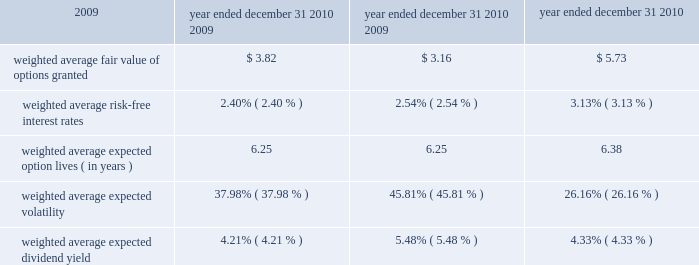Kimco realty corporation and subsidiaries notes to consolidated financial statements , continued other 2014 in connection with the construction of its development projects and related infrastructure , certain public agencies require posting of performance and surety bonds to guarantee that the company 2019s obligations are satisfied .
These bonds expire upon the completion of the improvements and infrastructure .
As of december 31 , 2010 , there were approximately $ 45.3 million in performance and surety bonds outstanding .
As of december 31 , 2010 , the company had accrued $ 3.8 million in connection with a legal claim related to a previously sold ground-up development project .
The company is currently negotiating with the plaintiff to settle this claim and believes that the prob- able settlement amount will approximate the amount accrued .
The company is subject to various other legal proceedings and claims that arise in the ordinary course of business .
Management believes that the final outcome of such matters will not have a material adverse effect on the financial position , results of operations or liquidity of the company .
23 .
Incentive plans : the company maintains two equity participation plans , the second amended and restated 1998 equity participation plan ( the 201cprior plan 201d ) and the 2010 equity participation plan ( the 201c2010 plan 201d ) ( collectively , the 201cplans 201d ) .
The prior plan provides for a maxi- mum of 47000000 shares of the company 2019s common stock to be issued for qualified and non-qualified options and restricted stock grants .
The 2010 plan provides for a maximum of 5000000 shares of the company 2019s common stock to be issued for qualified and non-qualified options , restricted stock , performance awards and other awards , plus the number of shares of common stock which are or become available for issuance under the prior plan and which are not thereafter issued under the prior plan , subject to certain conditions .
Unless otherwise determined by the board of directors at its sole discretion , options granted under the plans generally vest ratably over a range of three to five years , expire ten years from the date of grant and are exercisable at the market price on the date of grant .
Restricted stock grants generally vest ( i ) 100% ( 100 % ) on the fourth or fifth anniversary of the grant , ( ii ) ratably over three or four years or ( iii ) over three years at 50% ( 50 % ) after two years and 50% ( 50 % ) after the third year .
Performance share awards may provide a right to receive shares of restricted stock based on the company 2019s performance relative to its peers , as defined , or based on other performance criteria as determined by the board of directors .
In addition , the plans provide for the granting of certain options and restricted stock to each of the company 2019s non-employee directors ( the 201cindependent directors 201d ) and permits such independent directors to elect to receive deferred stock awards in lieu of directors 2019 fees .
The company accounts for stock options in accordance with fasb 2019s compensation 2014stock compensation guidance which requires that all share based payments to employees , including grants of employee stock options , be recognized in the statement of operations over the service period based on their fair values .
The fair value of each option award is estimated on the date of grant using the black-scholes option pricing formula .
The assump- tion for expected volatility has a significant affect on the grant date fair value .
Volatility is determined based on the historical equity of common stock for the most recent historical period equal to the expected term of the options plus an implied volatility measure .
The more significant assumptions underlying the determination of fair values for options granted during 2010 , 2009 and 2008 were as follows : year ended december 31 , 2010 2009 2008 .

What is the growth rate in weighted average fair value of options granted in 2009? 
Computations: ((3.16 - 5.73) / 5.73)
Answer: -0.44852. Kimco realty corporation and subsidiaries notes to consolidated financial statements , continued other 2014 in connection with the construction of its development projects and related infrastructure , certain public agencies require posting of performance and surety bonds to guarantee that the company 2019s obligations are satisfied .
These bonds expire upon the completion of the improvements and infrastructure .
As of december 31 , 2010 , there were approximately $ 45.3 million in performance and surety bonds outstanding .
As of december 31 , 2010 , the company had accrued $ 3.8 million in connection with a legal claim related to a previously sold ground-up development project .
The company is currently negotiating with the plaintiff to settle this claim and believes that the prob- able settlement amount will approximate the amount accrued .
The company is subject to various other legal proceedings and claims that arise in the ordinary course of business .
Management believes that the final outcome of such matters will not have a material adverse effect on the financial position , results of operations or liquidity of the company .
23 .
Incentive plans : the company maintains two equity participation plans , the second amended and restated 1998 equity participation plan ( the 201cprior plan 201d ) and the 2010 equity participation plan ( the 201c2010 plan 201d ) ( collectively , the 201cplans 201d ) .
The prior plan provides for a maxi- mum of 47000000 shares of the company 2019s common stock to be issued for qualified and non-qualified options and restricted stock grants .
The 2010 plan provides for a maximum of 5000000 shares of the company 2019s common stock to be issued for qualified and non-qualified options , restricted stock , performance awards and other awards , plus the number of shares of common stock which are or become available for issuance under the prior plan and which are not thereafter issued under the prior plan , subject to certain conditions .
Unless otherwise determined by the board of directors at its sole discretion , options granted under the plans generally vest ratably over a range of three to five years , expire ten years from the date of grant and are exercisable at the market price on the date of grant .
Restricted stock grants generally vest ( i ) 100% ( 100 % ) on the fourth or fifth anniversary of the grant , ( ii ) ratably over three or four years or ( iii ) over three years at 50% ( 50 % ) after two years and 50% ( 50 % ) after the third year .
Performance share awards may provide a right to receive shares of restricted stock based on the company 2019s performance relative to its peers , as defined , or based on other performance criteria as determined by the board of directors .
In addition , the plans provide for the granting of certain options and restricted stock to each of the company 2019s non-employee directors ( the 201cindependent directors 201d ) and permits such independent directors to elect to receive deferred stock awards in lieu of directors 2019 fees .
The company accounts for stock options in accordance with fasb 2019s compensation 2014stock compensation guidance which requires that all share based payments to employees , including grants of employee stock options , be recognized in the statement of operations over the service period based on their fair values .
The fair value of each option award is estimated on the date of grant using the black-scholes option pricing formula .
The assump- tion for expected volatility has a significant affect on the grant date fair value .
Volatility is determined based on the historical equity of common stock for the most recent historical period equal to the expected term of the options plus an implied volatility measure .
The more significant assumptions underlying the determination of fair values for options granted during 2010 , 2009 and 2008 were as follows : year ended december 31 , 2010 2009 2008 .

What is the growth rate in weighted average fair value of options granted in 2010? 
Computations: ((3.82 - 3.16) / 3.16)
Answer: 0.20886. 